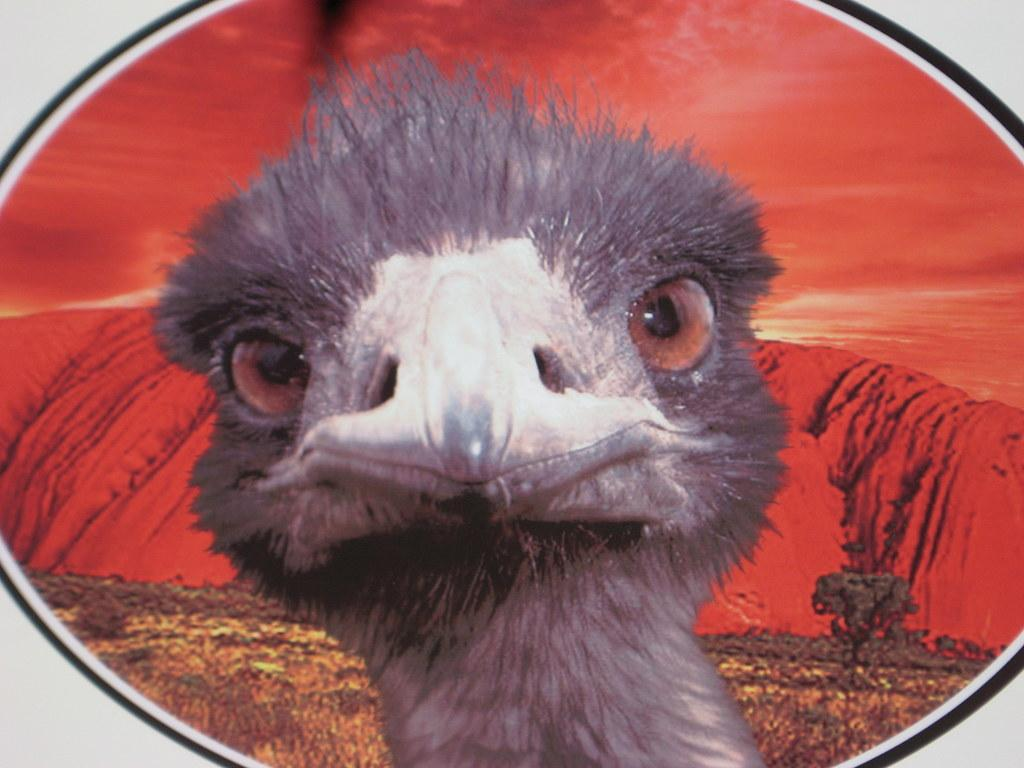What is featured in the image? There is a poster in the image. What is shown on the poster? The poster depicts a bird. What colors are present in the background of the poster? The background of the poster contains red and brown colors. What type of feast is being prepared in the image? There is no feast present in the image; it only features a poster with a bird on it. How many crates are visible in the image? There are no crates visible in the image. 